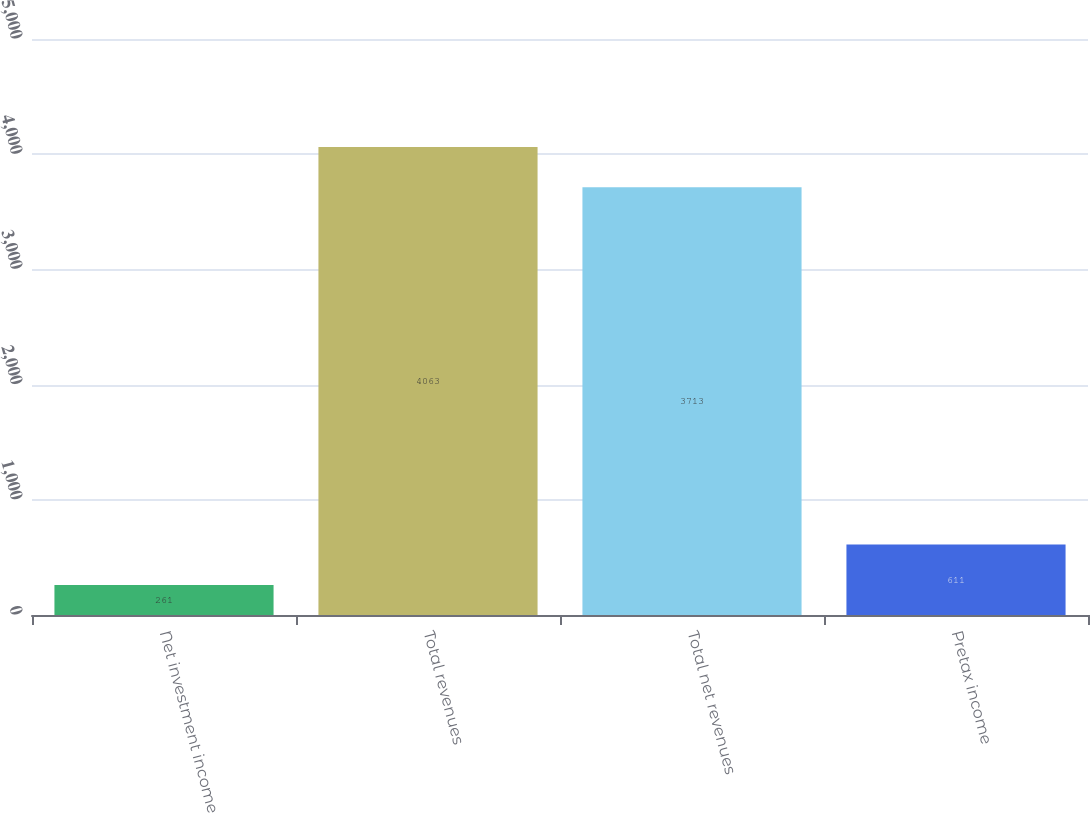Convert chart to OTSL. <chart><loc_0><loc_0><loc_500><loc_500><bar_chart><fcel>Net investment income<fcel>Total revenues<fcel>Total net revenues<fcel>Pretax income<nl><fcel>261<fcel>4063<fcel>3713<fcel>611<nl></chart> 